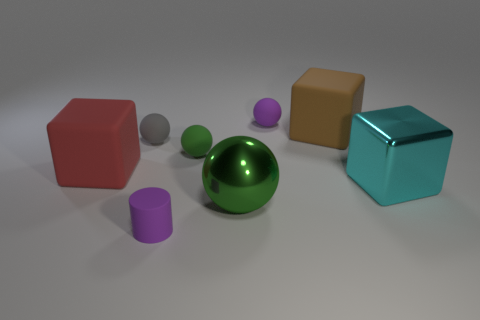Is there a green ball that has the same material as the large cyan block?
Keep it short and to the point. Yes. Are the small object in front of the big cyan metallic block and the big thing that is in front of the large cyan metallic thing made of the same material?
Offer a very short reply. No. Are there an equal number of big brown things that are left of the small gray rubber object and big metallic things that are right of the metallic ball?
Provide a short and direct response. No. The matte cylinder that is the same size as the gray sphere is what color?
Provide a succinct answer. Purple. Is there a tiny sphere that has the same color as the small matte cylinder?
Offer a very short reply. Yes. How many objects are tiny purple rubber cylinders that are in front of the small gray sphere or large gray shiny cylinders?
Provide a succinct answer. 1. What number of other objects are there of the same size as the green rubber object?
Give a very brief answer. 3. There is a block in front of the large block on the left side of the big matte cube behind the gray matte object; what is its material?
Provide a short and direct response. Metal. How many blocks are either blue objects or large brown matte objects?
Your response must be concise. 1. Are there more large metallic balls that are behind the big brown object than small purple objects that are in front of the red rubber thing?
Your response must be concise. No. 